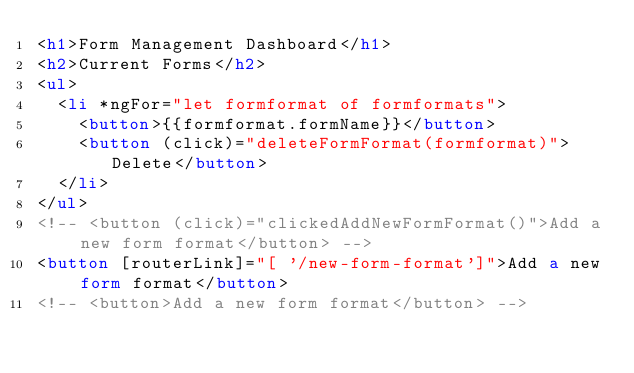Convert code to text. <code><loc_0><loc_0><loc_500><loc_500><_HTML_><h1>Form Management Dashboard</h1>
<h2>Current Forms</h2>
<ul>
  <li *ngFor="let formformat of formformats">
    <button>{{formformat.formName}}</button>
    <button (click)="deleteFormFormat(formformat)">Delete</button>
  </li>
</ul>
<!-- <button (click)="clickedAddNewFormFormat()">Add a new form format</button> -->
<button [routerLink]="[ '/new-form-format']">Add a new form format</button>
<!-- <button>Add a new form format</button> --></code> 